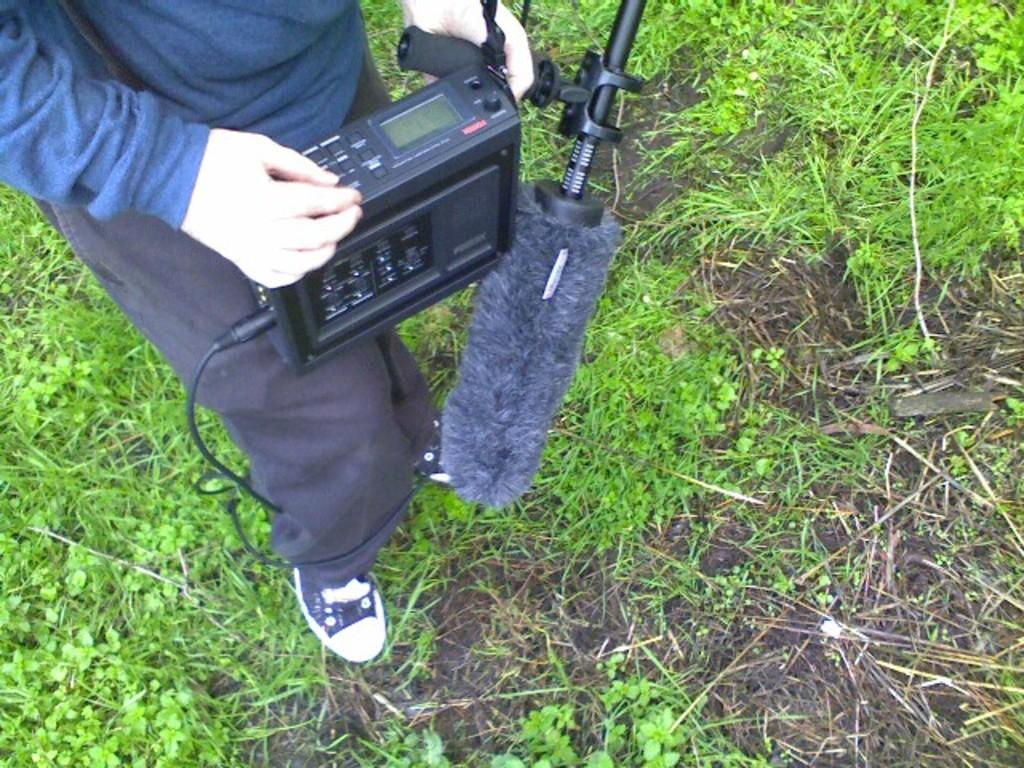What can be seen in the image? There is a person in the image. What is the person holding in their hand? The person is holding an electronic device in their hand. What type of surface is the person walking on? The person is walking on a grass surface. Is the person holding an umbrella in the image? No, the person is not holding an umbrella in the image; they are holding an electronic device. 